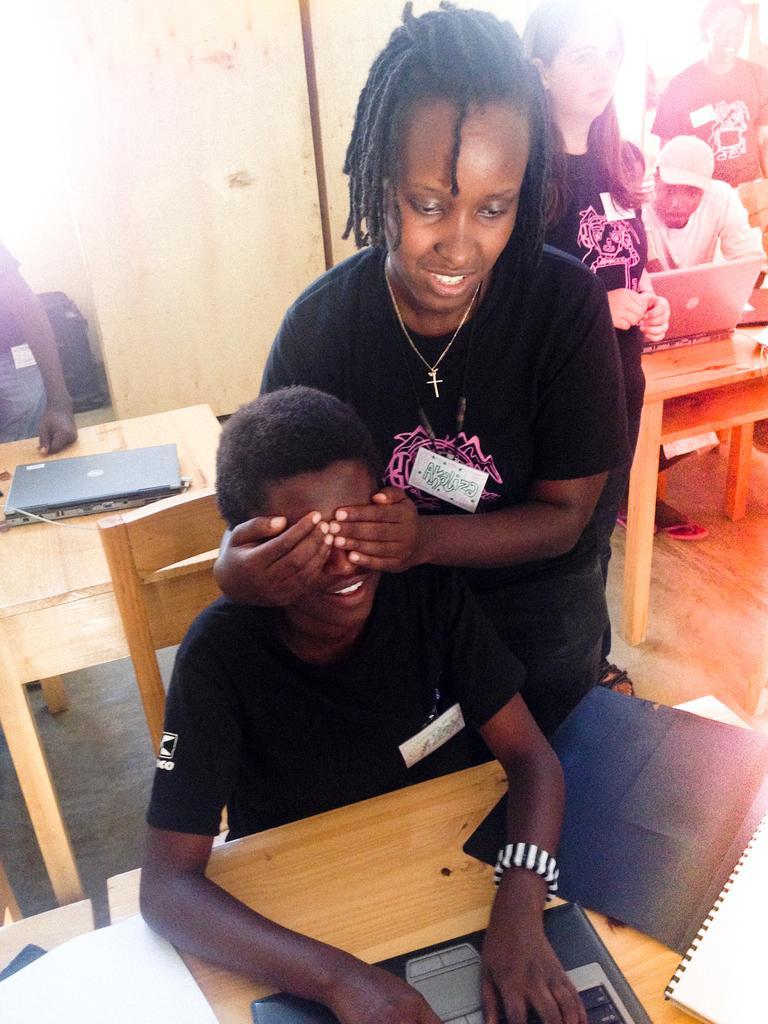How would you summarize this image in a sentence or two? In the picture we can see a woman standing and closing the eyes of a person who is sitting and they are in black T-shirts and behind them, we can see a table with a laptop on it and beside it, we can see a woman standing with loose hair beside her we can see a man sitting and watching something in the laptop which is on the table. 